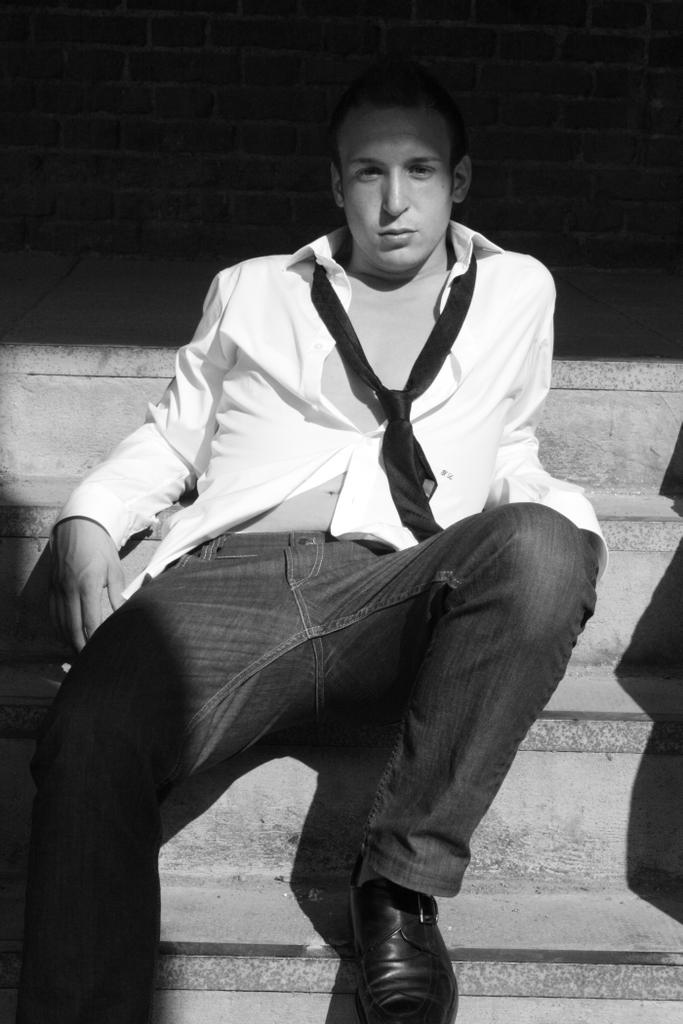What is the person in the image doing? The person is sitting on the stairs in the image. What is the color scheme of the image? The image is in black and white. What type of haircut does the person have in the image? There is no information about the person's haircut in the image, as it is in black and white and does not provide details about the person's appearance. 